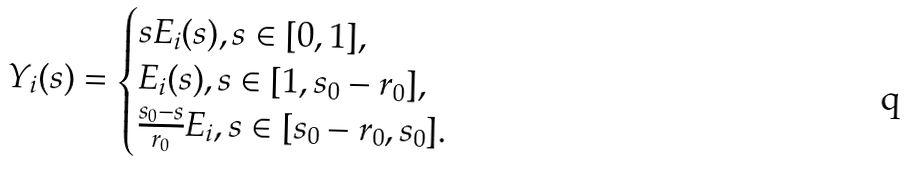<formula> <loc_0><loc_0><loc_500><loc_500>Y _ { i } ( s ) = \begin{cases} s E _ { i } ( s ) , s \in [ 0 , 1 ] , \\ E _ { i } ( s ) , s \in [ 1 , s _ { 0 } - r _ { 0 } ] , \\ \frac { s _ { 0 } - s } { r _ { 0 } } E _ { i } , s \in [ s _ { 0 } - r _ { 0 } , s _ { 0 } ] . \end{cases}</formula> 